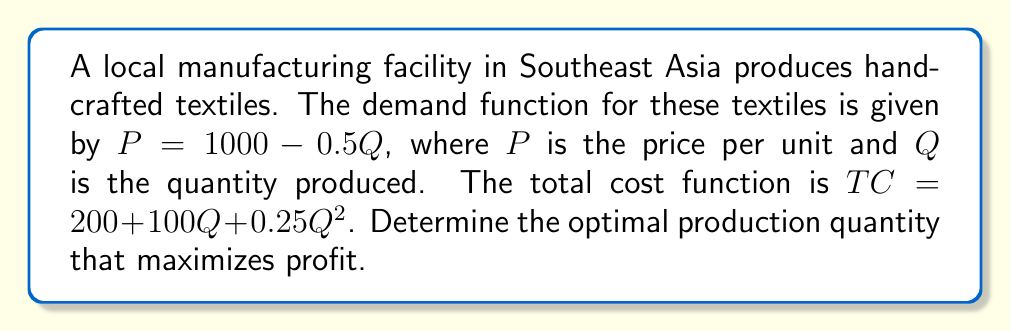What is the answer to this math problem? To find the optimal production quantity, we need to maximize the profit function. Let's follow these steps:

1) First, let's define the profit function:
   Profit = Total Revenue - Total Cost
   $\pi = TR - TC$

2) Total Revenue (TR) is price times quantity:
   $TR = PQ = (1000 - 0.5Q)Q = 1000Q - 0.5Q^2$

3) We're given the Total Cost (TC) function:
   $TC = 200 + 100Q + 0.25Q^2$

4) Now, let's write out the profit function:
   $\pi = TR - TC = (1000Q - 0.5Q^2) - (200 + 100Q + 0.25Q^2)$
   $\pi = 1000Q - 0.5Q^2 - 200 - 100Q - 0.25Q^2$
   $\pi = 900Q - 0.75Q^2 - 200$

5) To maximize profit, we find where the derivative of the profit function equals zero:
   $\frac{d\pi}{dQ} = 900 - 1.5Q = 0$

6) Solve this equation:
   $900 - 1.5Q = 0$
   $-1.5Q = -900$
   $Q = 600$

7) To confirm this is a maximum (not a minimum), we can check the second derivative:
   $\frac{d^2\pi}{dQ^2} = -1.5$
   Since this is negative, we confirm that $Q = 600$ gives a maximum profit.

Therefore, the optimal production quantity is 600 units.
Answer: 600 units 